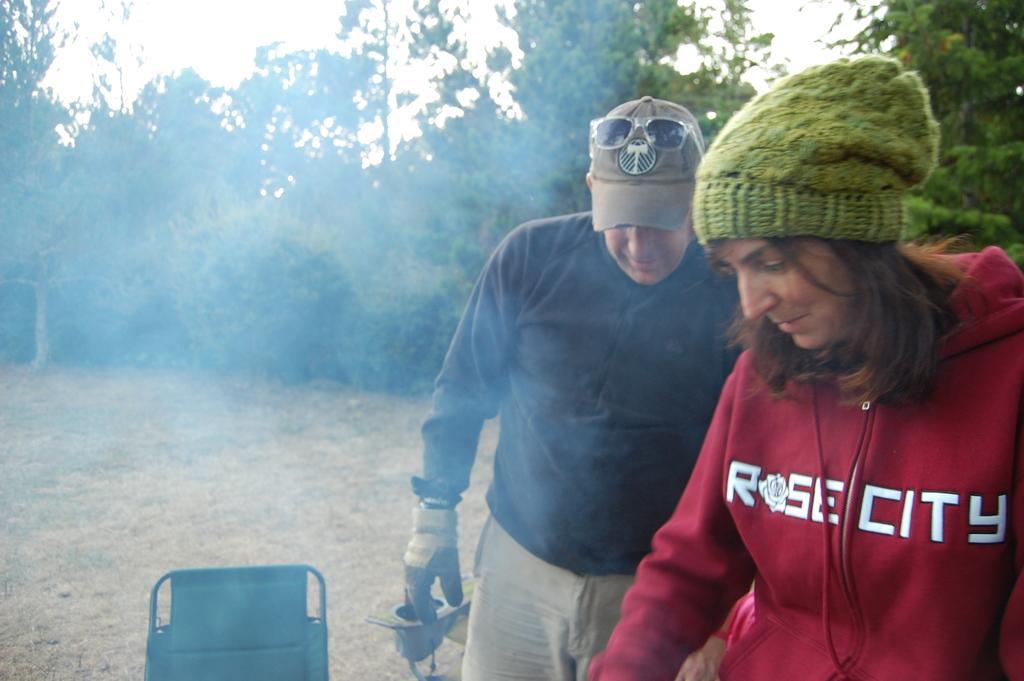Please provide a concise description of this image. In this image there is a woman on the right side. Beside her there is a man. At the bottom there is a chair. In the background there are trees. In the middle there is smoke. The woman is wearing a green colour cap. 